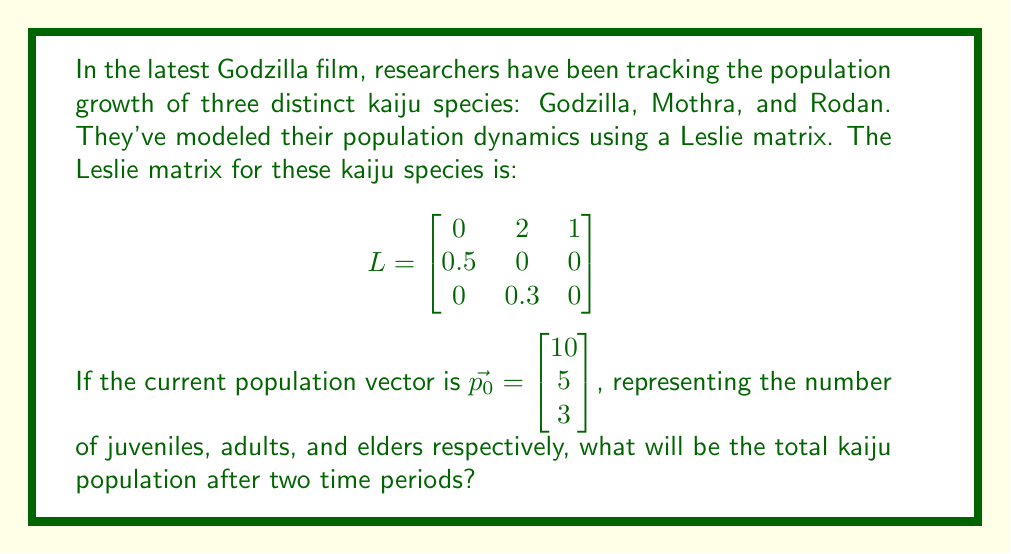Could you help me with this problem? Let's approach this step-by-step:

1) The Leslie matrix $L$ represents the transition between age classes and reproduction rates. To find the population after two time periods, we need to multiply the Leslie matrix by itself and then by the initial population vector.

2) First, let's calculate $L^2$:

   $$L^2 = \begin{bmatrix}
   0 & 2 & 1 \\
   0.5 & 0 & 0 \\
   0 & 0.3 & 0
   \end{bmatrix} \times \begin{bmatrix}
   0 & 2 & 1 \\
   0.5 & 0 & 0 \\
   0 & 0.3 & 0
   \end{bmatrix}$$

   $$L^2 = \begin{bmatrix}
   1 & 0.6 & 0 \\
   0 & 1 & 0.5 \\
   0.15 & 0 & 0
   \end{bmatrix}$$

3) Now, we multiply $L^2$ by the initial population vector $\vec{p_0}$:

   $$\vec{p_2} = L^2 \vec{p_0} = \begin{bmatrix}
   1 & 0.6 & 0 \\
   0 & 1 & 0.5 \\
   0.15 & 0 & 0
   \end{bmatrix} \times \begin{bmatrix}
   10 \\
   5 \\
   3
   \end{bmatrix}$$

4) Performing the matrix multiplication:

   $$\vec{p_2} = \begin{bmatrix}
   1(10) + 0.6(5) + 0(3) \\
   0(10) + 1(5) + 0.5(3) \\
   0.15(10) + 0(5) + 0(3)
   \end{bmatrix} = \begin{bmatrix}
   13 \\
   6.5 \\
   1.5
   \end{bmatrix}$$

5) To find the total population, we sum the components of $\vec{p_2}$:

   Total population = 13 + 6.5 + 1.5 = 21

Therefore, after two time periods, the total kaiju population will be 21.
Answer: 21 kaiju 